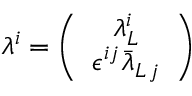Convert formula to latex. <formula><loc_0><loc_0><loc_500><loc_500>\lambda ^ { i } = \left ( \begin{array} { c } { { \lambda _ { L } ^ { i } } } \\ { { \epsilon ^ { i j } \bar { \lambda } _ { L \, j } } } \end{array} \right )</formula> 